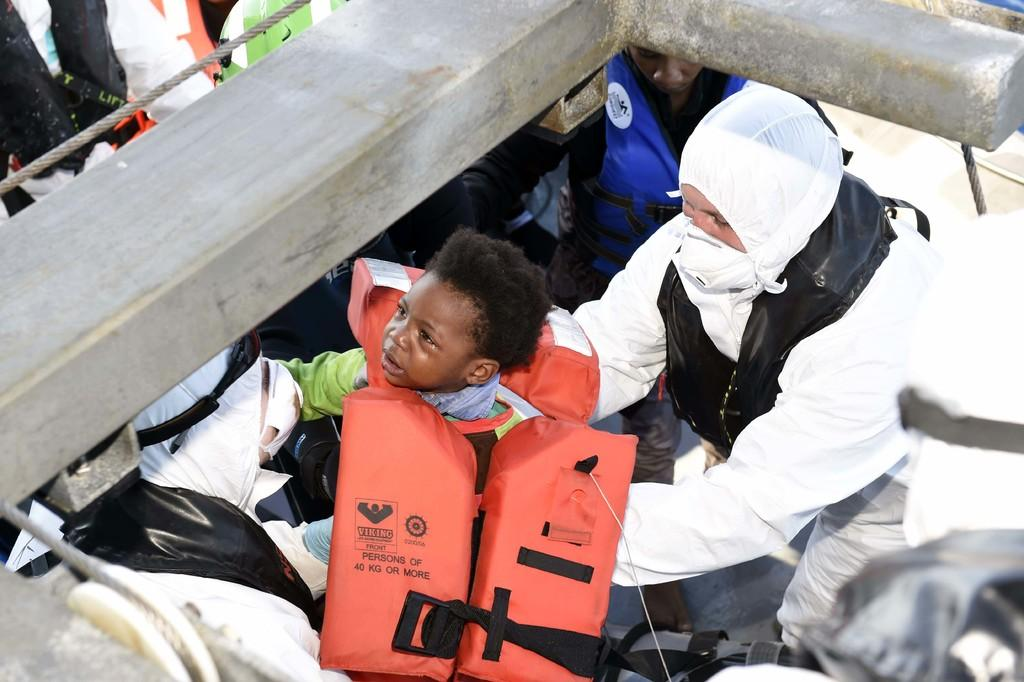How many people are in the image? There are people in the image, but the exact number is not specified. What is the kid wearing in the image? The kid is wearing a life jacket in the image. What protective gear is a person wearing in the image? A person is wearing a mask in the image. What object can be seen in the image? There is an object in the image, but its description is not provided. What is the purpose of the rope in the image? The purpose of the rope in the image is not specified. What type of prose is being recited by the people in the image? There is no indication in the image that people are reciting any prose. What type of polish is being applied to the object in the image? There is no mention of polish or any object being polished in the image. 